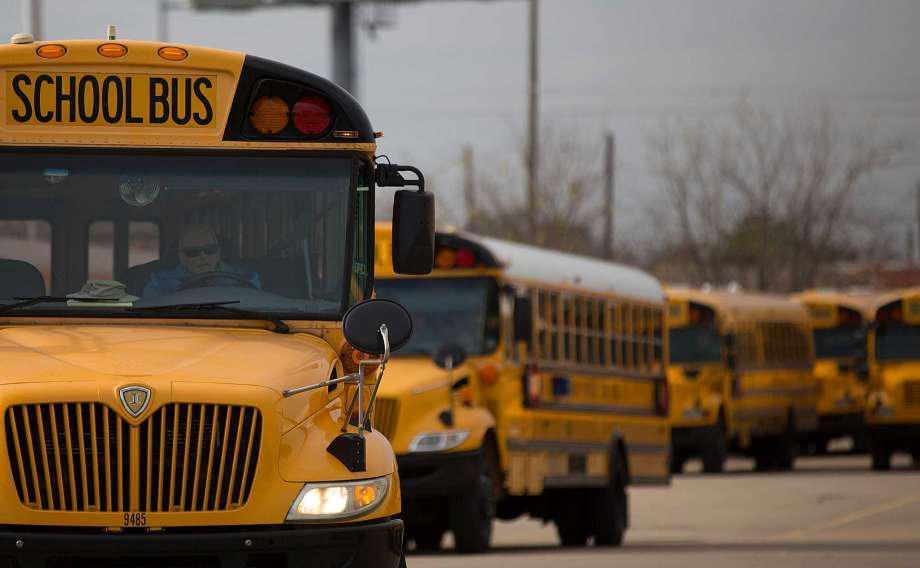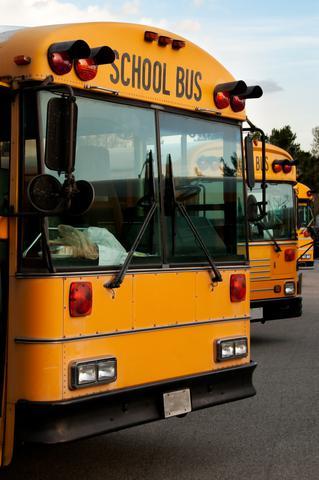The first image is the image on the left, the second image is the image on the right. For the images shown, is this caption "People are standing outside the bus in the image on the right." true? Answer yes or no. No. The first image is the image on the left, the second image is the image on the right. Given the left and right images, does the statement "The right image shows at least one person standing on a curb by the open door of a parked yellow bus with a non-flat front." hold true? Answer yes or no. No. 